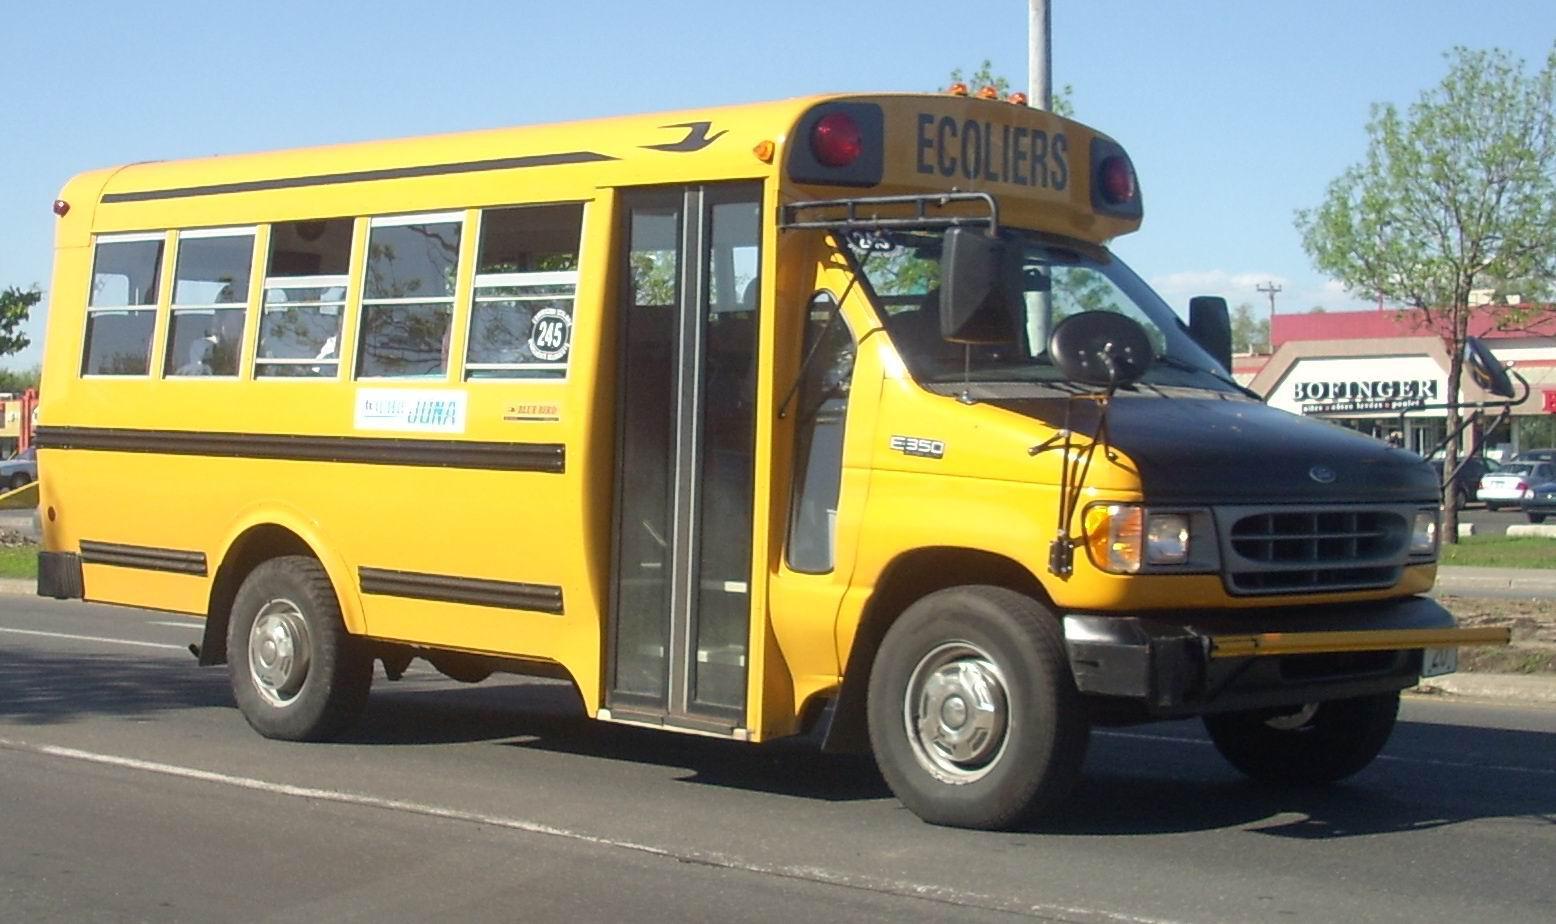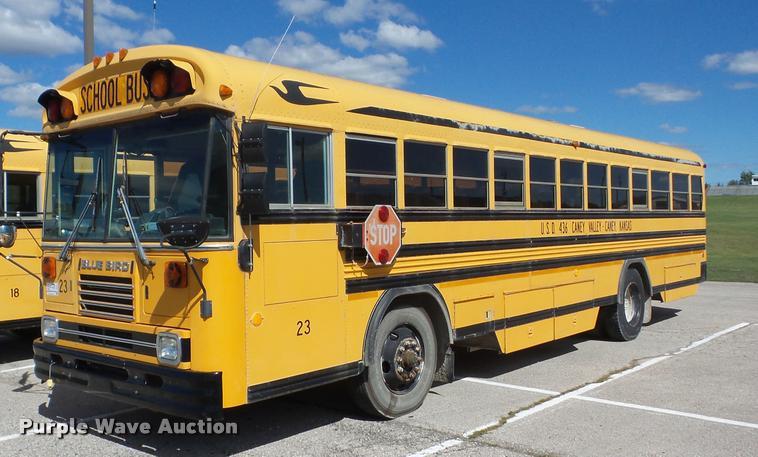The first image is the image on the left, the second image is the image on the right. Evaluate the accuracy of this statement regarding the images: "One image shows a bus with a flat front, and the other image shows a bus with a non-flat front.". Is it true? Answer yes or no. Yes. The first image is the image on the left, the second image is the image on the right. Considering the images on both sides, is "Exactly one bus stop sign is visible." valid? Answer yes or no. Yes. 